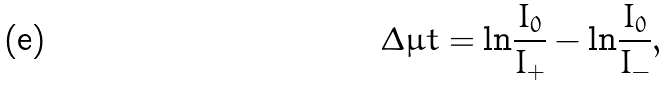<formula> <loc_0><loc_0><loc_500><loc_500>\Delta \mu t = { \ln } \frac { I _ { 0 } } { I _ { + } } - { \ln } \frac { I _ { 0 } } { I _ { - } } ,</formula> 